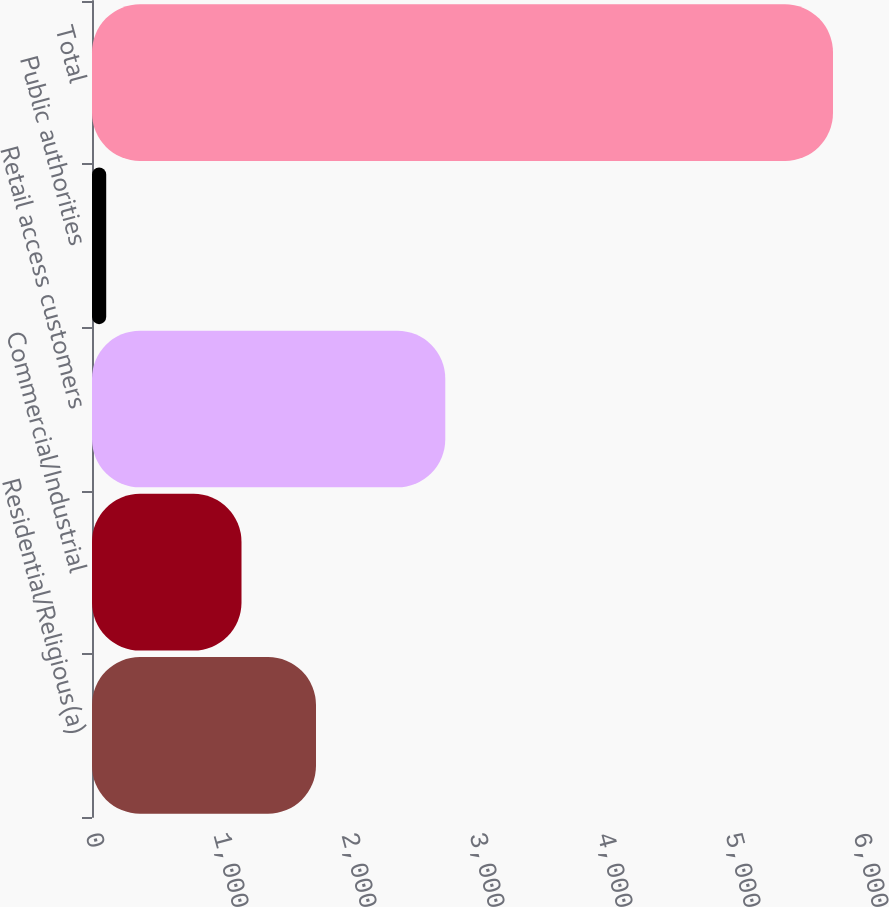Convert chart. <chart><loc_0><loc_0><loc_500><loc_500><bar_chart><fcel>Residential/Religious(a)<fcel>Commercial/Industrial<fcel>Retail access customers<fcel>Public authorities<fcel>Total<nl><fcel>1750<fcel>1168<fcel>2760<fcel>111<fcel>5789<nl></chart> 